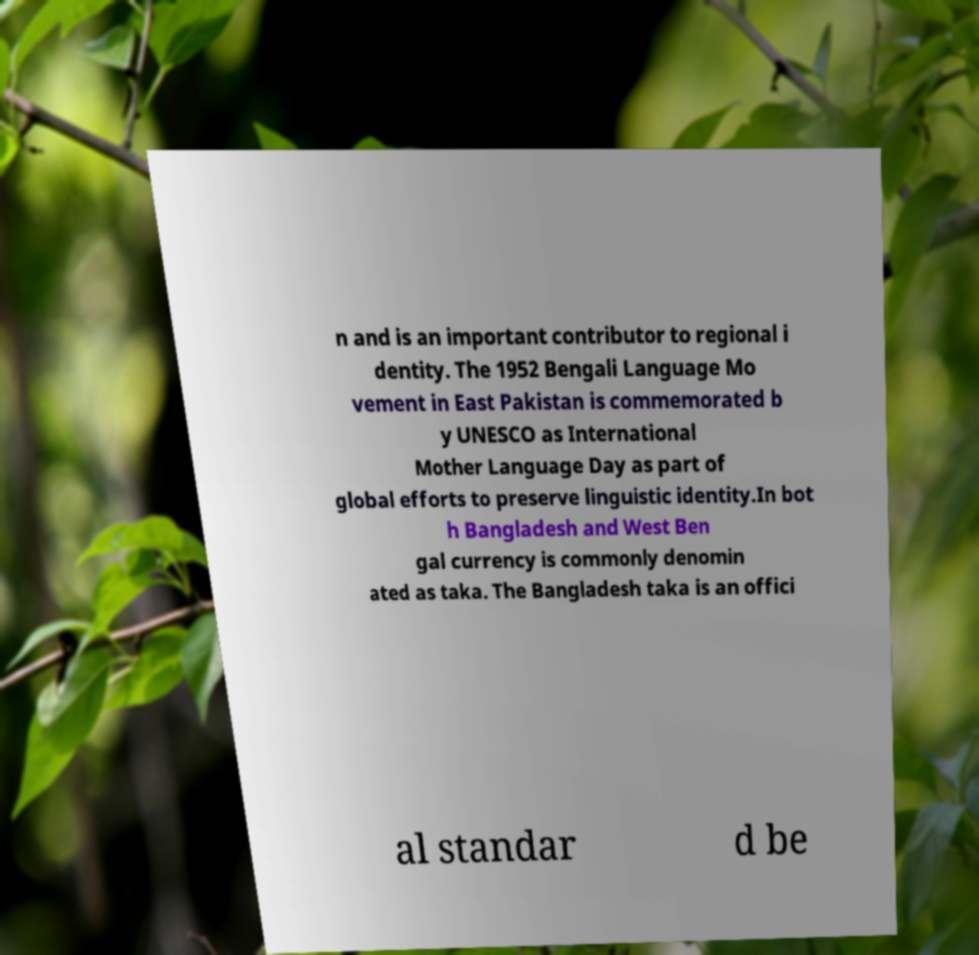Please read and relay the text visible in this image. What does it say? n and is an important contributor to regional i dentity. The 1952 Bengali Language Mo vement in East Pakistan is commemorated b y UNESCO as International Mother Language Day as part of global efforts to preserve linguistic identity.In bot h Bangladesh and West Ben gal currency is commonly denomin ated as taka. The Bangladesh taka is an offici al standar d be 